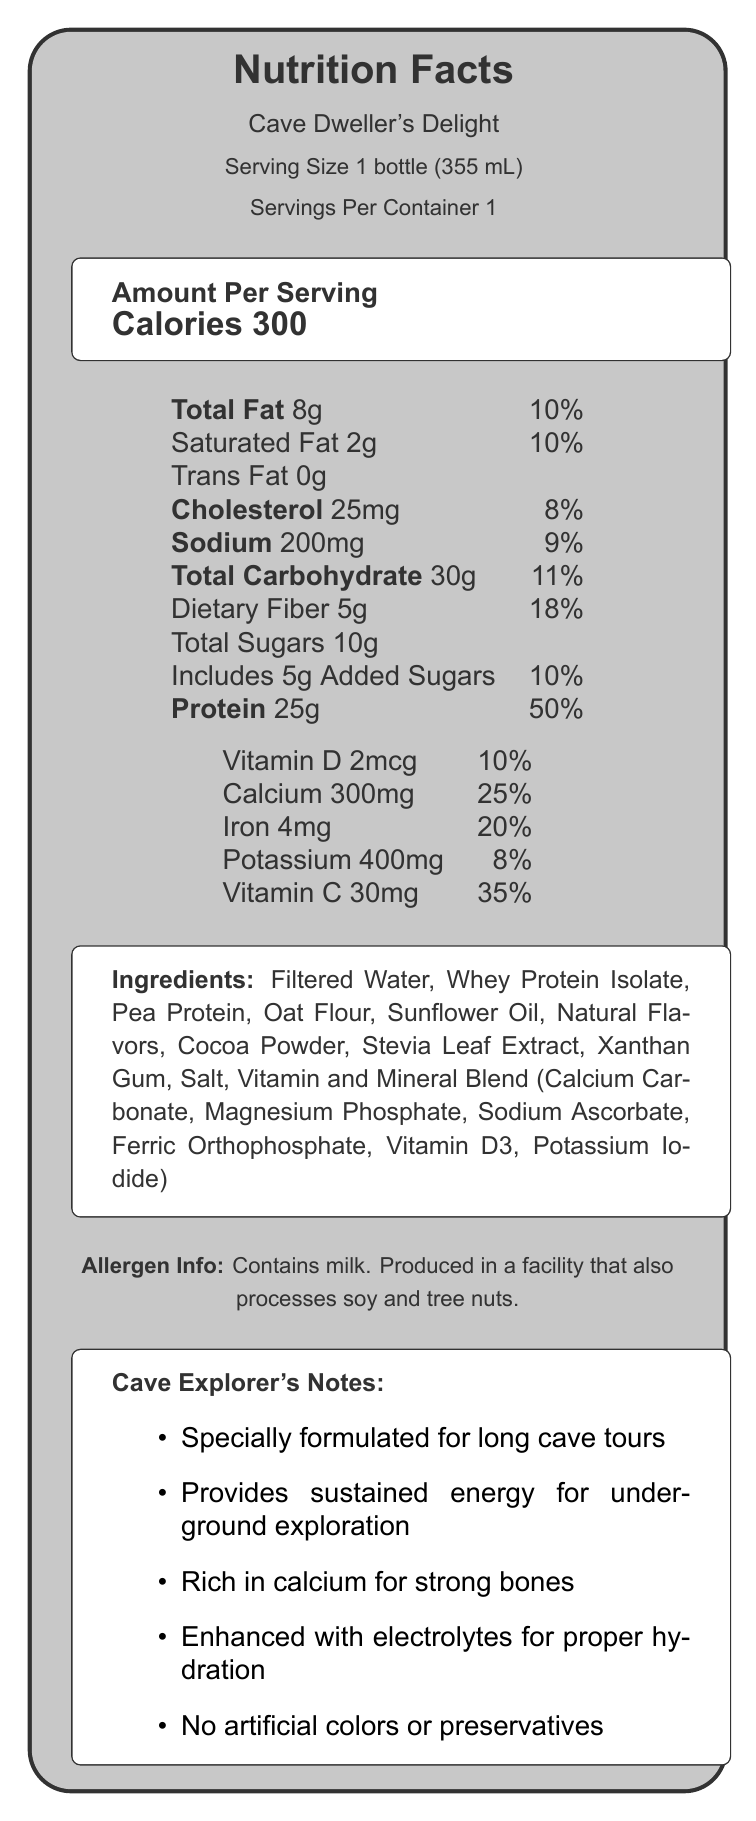what is the serving size of Cave Dweller's Delight? The document specifies that the serving size is 1 bottle, which is equivalent to 355 mL.
Answer: 1 bottle (355 mL) how many calories are in one serving? The document states that there are 300 calories per serving of Cave Dweller's Delight.
Answer: 300 what is the total amount of protein in one serving, and what percentage of the daily value does it represent? Each serving contains 25 grams of protein, which represents 50% of the daily value.
Answer: 25g, 50% list all the allergens mentioned in the allergen info section. The allergen info section mentions milk as an allergen.
Answer: Milk how much dietary fiber is in one serving of Cave Dweller's Delight? The document indicates that one serving contains 5 grams of dietary fiber.
Answer: 5g how much calcium does each serving provide? The document specifies that each serving provides 300mg of calcium.
Answer: 300mg what is the total fat content, and what percentage of the daily value does it represent? The document shows that the total fat content is 8 grams, which is 10% of the daily value.
Answer: 8g, 10% what is the vitamin c content per serving, and what percentage of the daily value does it represent? Each serving contains 30mg of Vitamin C, which is 35% of the daily value.
Answer: 30mg, 35% which of the following ingredients is not in Cave Dweller’s Delight? The document lists all the ingredients and specifies that there are no artificial colors in the product.
Answer: C. Artificial Colors how much cholesterol does Cave Dweller's Delight contain per serving? The document indicates that each serving contains 25mg of cholesterol.
Answer: 25mg what is a unique feature of Cave Dweller's Delight related to hydration? A. Contains high sodium B. Contains electrolytes C. Contains sugar D. Contains artificial preservatives The additional info section mentions that the product is enhanced with electrolytes for proper hydration.
Answer: B. Contains electrolytes does Cave Dweller’s Delight contain any added sugars? The document states that Cave Dweller's Delight includes 5 grams of added sugars.
Answer: Yes is Cave Dweller's Delight suitable for people with nut allergies? The allergen info section states that the product is produced in a facility that also processes tree nuts.
Answer: No summarize the main features of Cave Dweller's Delight as indicated in the document. The document details that Cave Dweller's Delight is designed for long cave tours, providing high protein, essential nutrients, and electrolytes while avoiding artificial colors and preservatives.
Answer: Cave Dweller's Delight is a high-protein meal replacement shake specially formulated for long cave tours, providing sustained energy and rich in calcium, with enhanced electrolytes for proper hydration. It contains no artificial colors or preservatives. Key nutrients include protein, calcium, vitamins, and dietary fiber. what is the total carbohydrate content per serving? The document lists the total carbohydrate content per serving as 30 grams.
Answer: 30g how much added sugars does Cave Dweller's Delight contain? The document specifies that the product includes 5 grams of added sugars.
Answer: 5g what vitamin blend ingredients are included in the product? The document lists these ingredients as part of the Vitamin and Mineral Blend.
Answer: Calcium Carbonate, Magnesium Phosphate, Sodium Ascorbate, Ferric Orthophosphate, Vitamin D3, Potassium Iodide does Cave Dweller’s Delight contain gluten? The document does not provide information on whether the product contains gluten.
Answer: Not enough information 